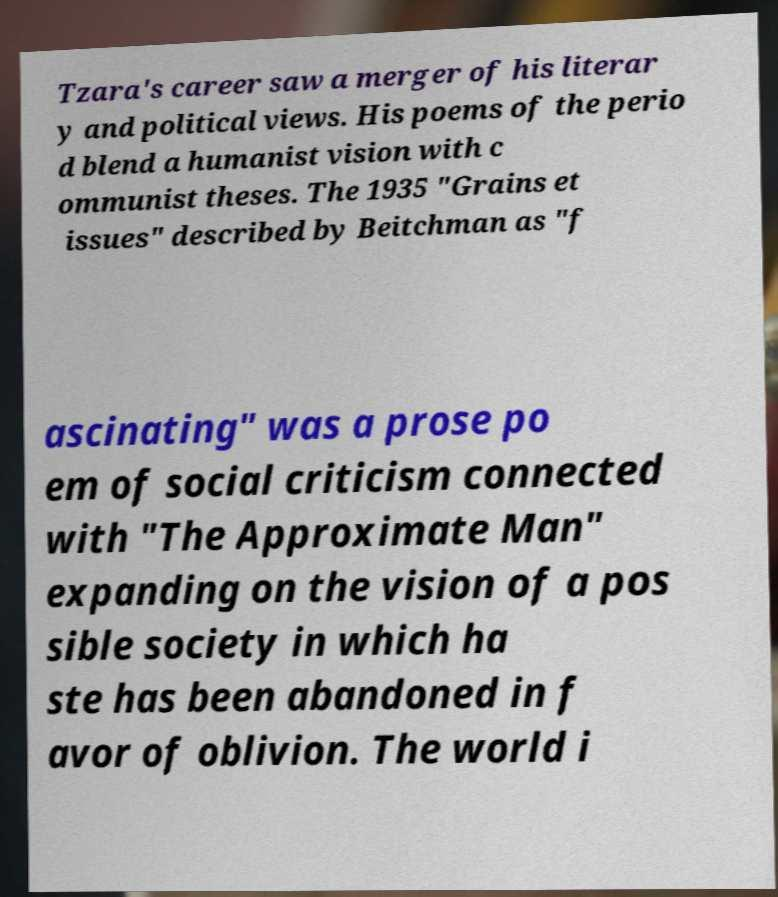Please read and relay the text visible in this image. What does it say? Tzara's career saw a merger of his literar y and political views. His poems of the perio d blend a humanist vision with c ommunist theses. The 1935 "Grains et issues" described by Beitchman as "f ascinating" was a prose po em of social criticism connected with "The Approximate Man" expanding on the vision of a pos sible society in which ha ste has been abandoned in f avor of oblivion. The world i 